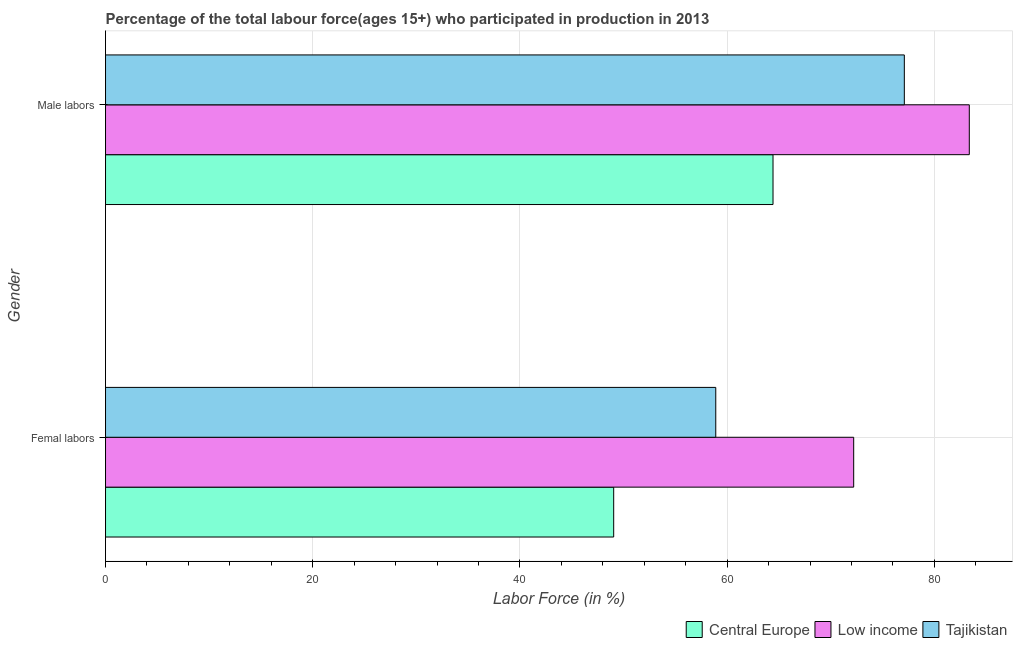How many different coloured bars are there?
Ensure brevity in your answer.  3. Are the number of bars per tick equal to the number of legend labels?
Your answer should be very brief. Yes. Are the number of bars on each tick of the Y-axis equal?
Offer a terse response. Yes. How many bars are there on the 1st tick from the bottom?
Offer a very short reply. 3. What is the label of the 1st group of bars from the top?
Keep it short and to the point. Male labors. What is the percentage of male labour force in Low income?
Your response must be concise. 83.37. Across all countries, what is the maximum percentage of female labor force?
Provide a short and direct response. 72.21. Across all countries, what is the minimum percentage of female labor force?
Ensure brevity in your answer.  49.05. In which country was the percentage of male labour force minimum?
Give a very brief answer. Central Europe. What is the total percentage of female labor force in the graph?
Offer a terse response. 180.16. What is the difference between the percentage of male labour force in Low income and that in Central Europe?
Keep it short and to the point. 18.95. What is the difference between the percentage of male labour force in Tajikistan and the percentage of female labor force in Low income?
Provide a succinct answer. 4.89. What is the average percentage of male labour force per country?
Keep it short and to the point. 74.97. What is the difference between the percentage of male labour force and percentage of female labor force in Low income?
Your response must be concise. 11.16. What is the ratio of the percentage of male labour force in Central Europe to that in Tajikistan?
Your response must be concise. 0.84. Is the percentage of male labour force in Central Europe less than that in Tajikistan?
Provide a succinct answer. Yes. What does the 2nd bar from the top in Male labors represents?
Your response must be concise. Low income. What does the 3rd bar from the bottom in Male labors represents?
Provide a short and direct response. Tajikistan. Are all the bars in the graph horizontal?
Offer a terse response. Yes. How many countries are there in the graph?
Ensure brevity in your answer.  3. Are the values on the major ticks of X-axis written in scientific E-notation?
Give a very brief answer. No. How many legend labels are there?
Your response must be concise. 3. What is the title of the graph?
Provide a succinct answer. Percentage of the total labour force(ages 15+) who participated in production in 2013. What is the label or title of the X-axis?
Make the answer very short. Labor Force (in %). What is the Labor Force (in %) in Central Europe in Femal labors?
Offer a terse response. 49.05. What is the Labor Force (in %) in Low income in Femal labors?
Provide a short and direct response. 72.21. What is the Labor Force (in %) of Tajikistan in Femal labors?
Offer a terse response. 58.9. What is the Labor Force (in %) of Central Europe in Male labors?
Make the answer very short. 64.43. What is the Labor Force (in %) of Low income in Male labors?
Offer a terse response. 83.37. What is the Labor Force (in %) in Tajikistan in Male labors?
Your answer should be compact. 77.1. Across all Gender, what is the maximum Labor Force (in %) in Central Europe?
Your answer should be compact. 64.43. Across all Gender, what is the maximum Labor Force (in %) in Low income?
Your response must be concise. 83.37. Across all Gender, what is the maximum Labor Force (in %) in Tajikistan?
Offer a terse response. 77.1. Across all Gender, what is the minimum Labor Force (in %) of Central Europe?
Your answer should be compact. 49.05. Across all Gender, what is the minimum Labor Force (in %) of Low income?
Offer a terse response. 72.21. Across all Gender, what is the minimum Labor Force (in %) in Tajikistan?
Your answer should be compact. 58.9. What is the total Labor Force (in %) of Central Europe in the graph?
Keep it short and to the point. 113.47. What is the total Labor Force (in %) of Low income in the graph?
Your answer should be compact. 155.58. What is the total Labor Force (in %) of Tajikistan in the graph?
Your answer should be compact. 136. What is the difference between the Labor Force (in %) in Central Europe in Femal labors and that in Male labors?
Your answer should be very brief. -15.38. What is the difference between the Labor Force (in %) of Low income in Femal labors and that in Male labors?
Give a very brief answer. -11.16. What is the difference between the Labor Force (in %) of Tajikistan in Femal labors and that in Male labors?
Your answer should be very brief. -18.2. What is the difference between the Labor Force (in %) in Central Europe in Femal labors and the Labor Force (in %) in Low income in Male labors?
Your response must be concise. -34.32. What is the difference between the Labor Force (in %) in Central Europe in Femal labors and the Labor Force (in %) in Tajikistan in Male labors?
Give a very brief answer. -28.05. What is the difference between the Labor Force (in %) in Low income in Femal labors and the Labor Force (in %) in Tajikistan in Male labors?
Your answer should be very brief. -4.89. What is the average Labor Force (in %) of Central Europe per Gender?
Offer a terse response. 56.74. What is the average Labor Force (in %) in Low income per Gender?
Provide a succinct answer. 77.79. What is the average Labor Force (in %) of Tajikistan per Gender?
Your answer should be very brief. 68. What is the difference between the Labor Force (in %) of Central Europe and Labor Force (in %) of Low income in Femal labors?
Provide a short and direct response. -23.17. What is the difference between the Labor Force (in %) in Central Europe and Labor Force (in %) in Tajikistan in Femal labors?
Ensure brevity in your answer.  -9.85. What is the difference between the Labor Force (in %) of Low income and Labor Force (in %) of Tajikistan in Femal labors?
Provide a succinct answer. 13.31. What is the difference between the Labor Force (in %) of Central Europe and Labor Force (in %) of Low income in Male labors?
Provide a succinct answer. -18.95. What is the difference between the Labor Force (in %) in Central Europe and Labor Force (in %) in Tajikistan in Male labors?
Your response must be concise. -12.67. What is the difference between the Labor Force (in %) in Low income and Labor Force (in %) in Tajikistan in Male labors?
Ensure brevity in your answer.  6.27. What is the ratio of the Labor Force (in %) in Central Europe in Femal labors to that in Male labors?
Your response must be concise. 0.76. What is the ratio of the Labor Force (in %) in Low income in Femal labors to that in Male labors?
Make the answer very short. 0.87. What is the ratio of the Labor Force (in %) in Tajikistan in Femal labors to that in Male labors?
Offer a very short reply. 0.76. What is the difference between the highest and the second highest Labor Force (in %) of Central Europe?
Ensure brevity in your answer.  15.38. What is the difference between the highest and the second highest Labor Force (in %) in Low income?
Make the answer very short. 11.16. What is the difference between the highest and the second highest Labor Force (in %) in Tajikistan?
Keep it short and to the point. 18.2. What is the difference between the highest and the lowest Labor Force (in %) of Central Europe?
Offer a very short reply. 15.38. What is the difference between the highest and the lowest Labor Force (in %) of Low income?
Your response must be concise. 11.16. What is the difference between the highest and the lowest Labor Force (in %) of Tajikistan?
Make the answer very short. 18.2. 